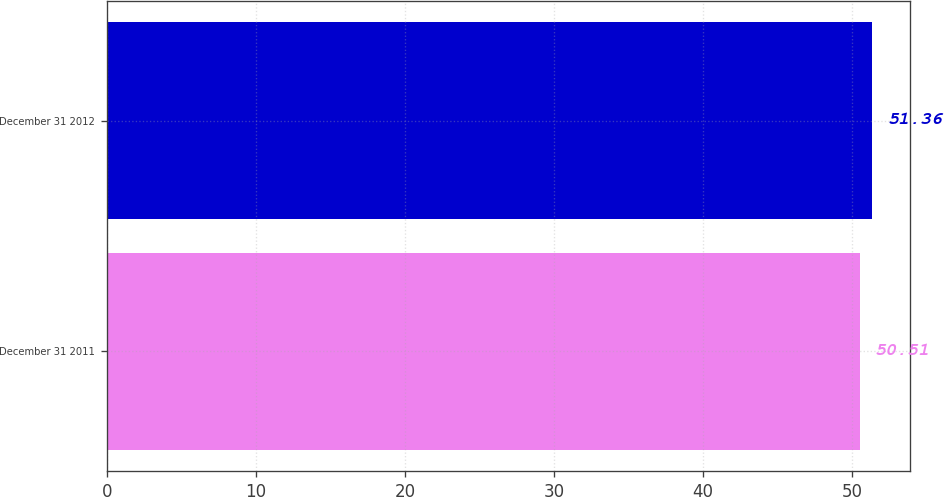Convert chart to OTSL. <chart><loc_0><loc_0><loc_500><loc_500><bar_chart><fcel>December 31 2011<fcel>December 31 2012<nl><fcel>50.51<fcel>51.36<nl></chart> 